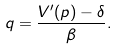Convert formula to latex. <formula><loc_0><loc_0><loc_500><loc_500>q = \frac { V ^ { \prime } ( p ) - \delta } { \beta } .</formula> 